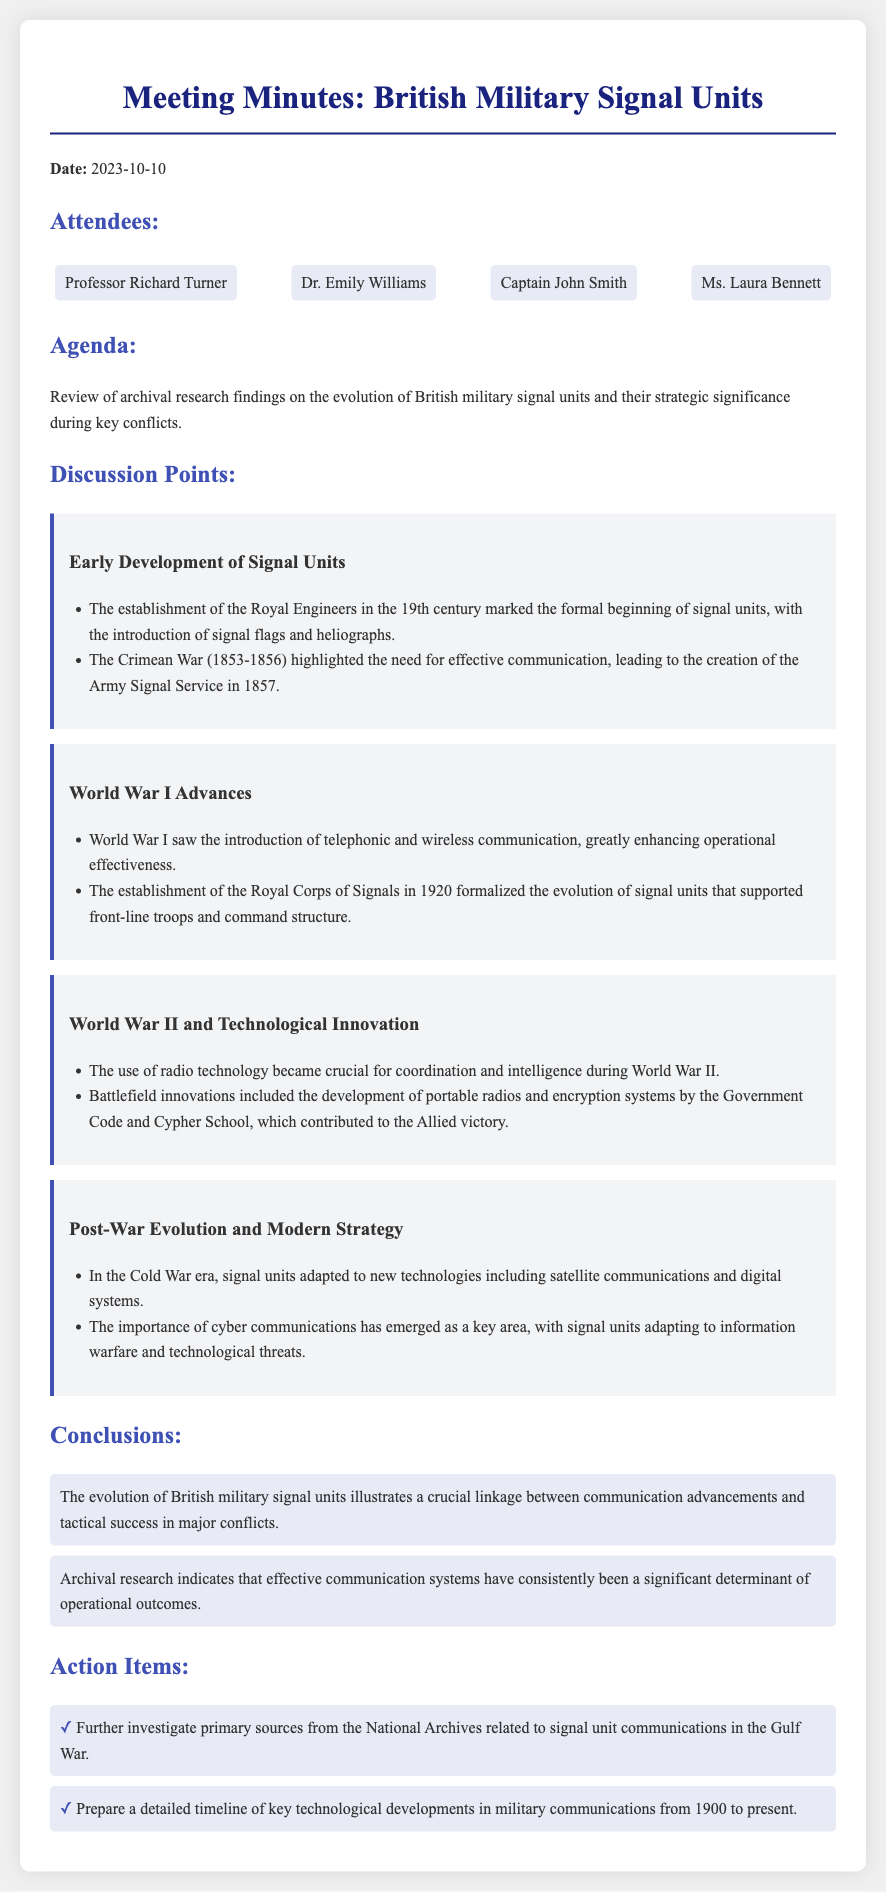What date was the meeting held? The date of the meeting is explicitly mentioned in the document as October 10, 2023.
Answer: October 10, 2023 Who introduced the Army Signal Service? The creation of the Army Signal Service in 1857 is discussed in the context of the Crimean War.
Answer: Crimean War What was established in 1920? A significant milestone in the evolution of signal units, which is noted in the discussion points, is the establishment of the Royal Corps of Signals.
Answer: Royal Corps of Signals What technology became crucial during World War II? The document discusses the importance of a specific technology used for coordination during World War II.
Answer: Radio technology What are the two action items listed? The document includes two specific action items that need to be addressed following the discussion.
Answer: Investigate primary sources, Prepare a detailed timeline What change occurred in the Cold War era? The document mentions a specific adaptation of signal units during the Cold War, showcasing their evolution.
Answer: New technologies What is the document type? The content describes the format and purpose of the document, which is a formal record of proceedings.
Answer: Meeting minutes What was emphasized as crucial for tactical success? The conclusions highlight the relationship between communication advancements and a specific aspect of military success.
Answer: Communication advancements 